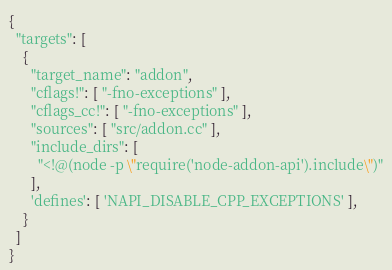<code> <loc_0><loc_0><loc_500><loc_500><_Python_>{
  "targets": [
    {
      "target_name": "addon",
      "cflags!": [ "-fno-exceptions" ],
      "cflags_cc!": [ "-fno-exceptions" ],
      "sources": [ "src/addon.cc" ],
      "include_dirs": [
        "<!@(node -p \"require('node-addon-api').include\")"
      ],
      'defines': [ 'NAPI_DISABLE_CPP_EXCEPTIONS' ],
    }
  ]
}</code> 